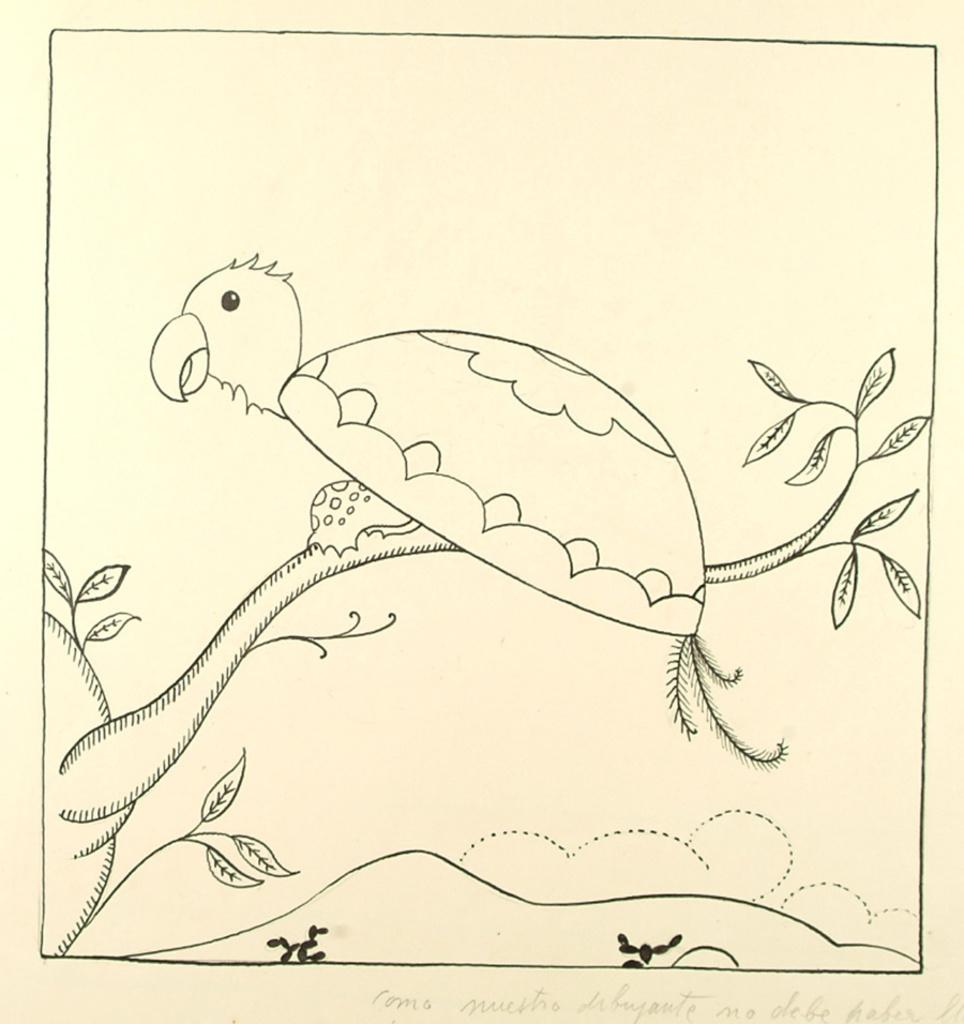What is depicted in the image? There is a sketch of a bird in the image. Where is the bird located in the image? The bird is on a plant in the image. Is there any text present in the image? Yes, there is text written on the bottom right of the image. What type of slope can be seen in the image? There is no slope present in the image; it features a sketch of a bird on a plant with accompanying text. How many strings are attached to the bird in the image? There are no strings attached to the bird in the image; it is a sketch of a bird on a plant with text. 